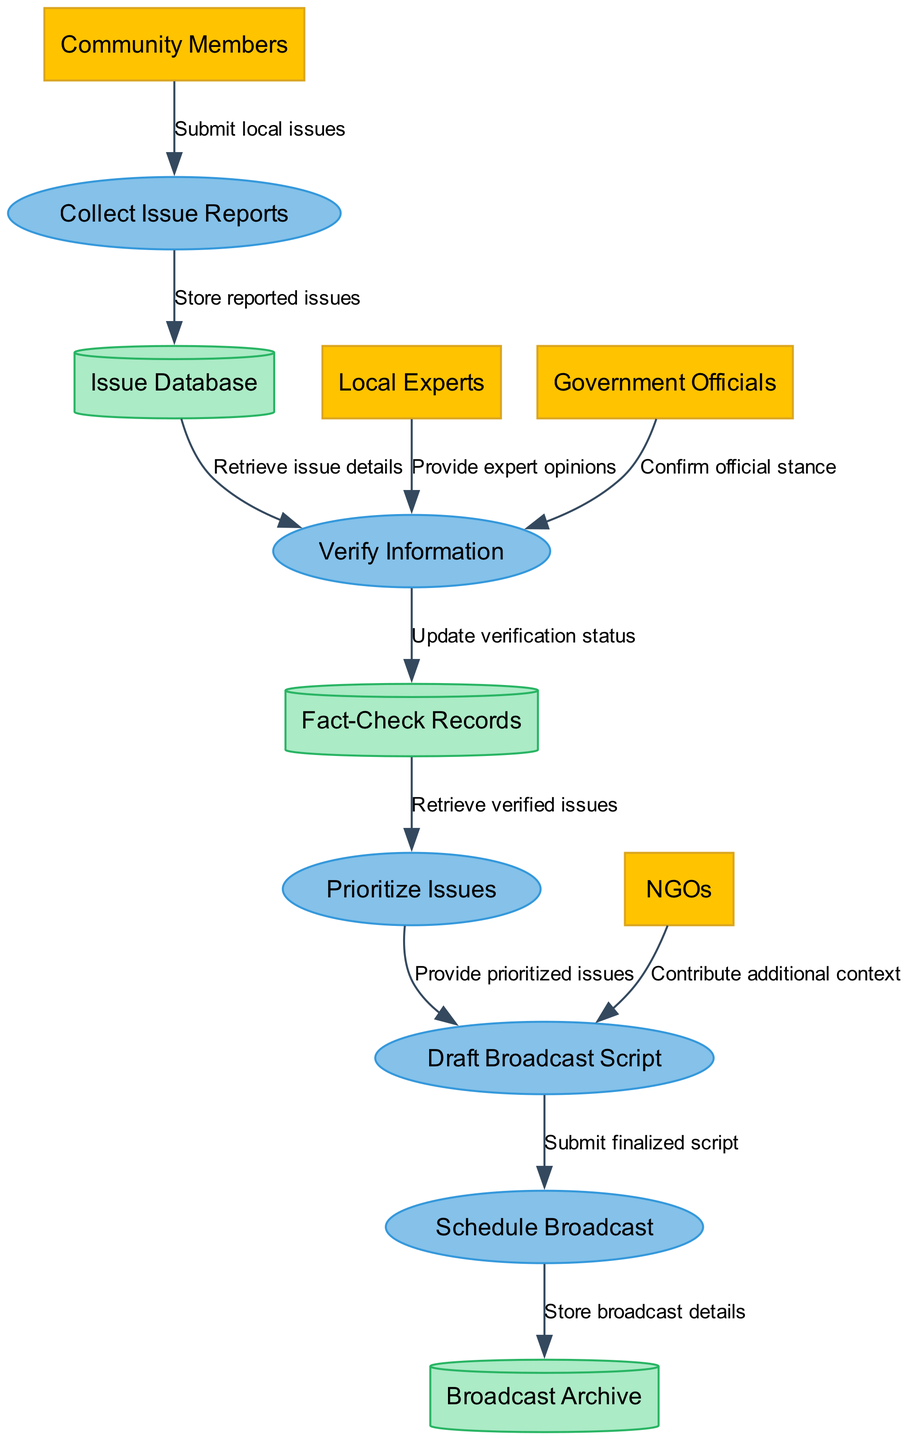What are the external entities in the diagram? The external entities listed in the diagram are Community Members, Local Experts, Government Officials, and NGOs. This is derived from the section where external entities are defined, directly indicating their roles in the workflow.
Answer: Community Members, Local Experts, Government Officials, NGOs How many processes are in the diagram? The diagram contains five processes: Collect Issue Reports, Verify Information, Prioritize Issues, Draft Broadcast Script, and Schedule Broadcast. Counting each of these identified processes yields the total number.
Answer: 5 What flow comes from Community Members? The flow from Community Members to the process Collect Issue Reports is labeled "Submit local issues." This relationship explicitly connects community members to the action of reporting local issues.
Answer: Submit local issues Which process retrieves details from the Issue Database? The process Verify Information retrieves details from the Issue Database. The diagram shows an arrow from Issue Database to Verify Information, indicating this flow of information.
Answer: Verify Information What is stored in Fact-Check Records? The verification status is updated in the Fact-Check Records. According to the data flow, after verifying information, there is a flow to update the verification status into this data store.
Answer: Update verification status Which external entity contributes additional context in the Draft Broadcast Script process? NGOs contribute additional context in the Draft Broadcast Script process. This contribution is specified by the flow from NGOs to Draft Broadcast Script, indicating their involvement.
Answer: NGOs What is the last process in the workflow? The last process in the workflow is Schedule Broadcast. This can be identified as it is the final process before details are stored in the Broadcast Archive.
Answer: Schedule Broadcast What type of data store is the Issue Database? The Issue Database is represented as a cylinder, which is a typical graphical representation for data stores in Data Flow Diagrams. This shape indicates it holds persistent data related to reported issues.
Answer: Cylinder How do verified issues flow into another process? Verified issues flow from Fact-Check Records to the Prioritize Issues process. This flow indicates that the information stored about verified issues is used directly to prioritize what should be addressed next.
Answer: Retrieve verified issues 